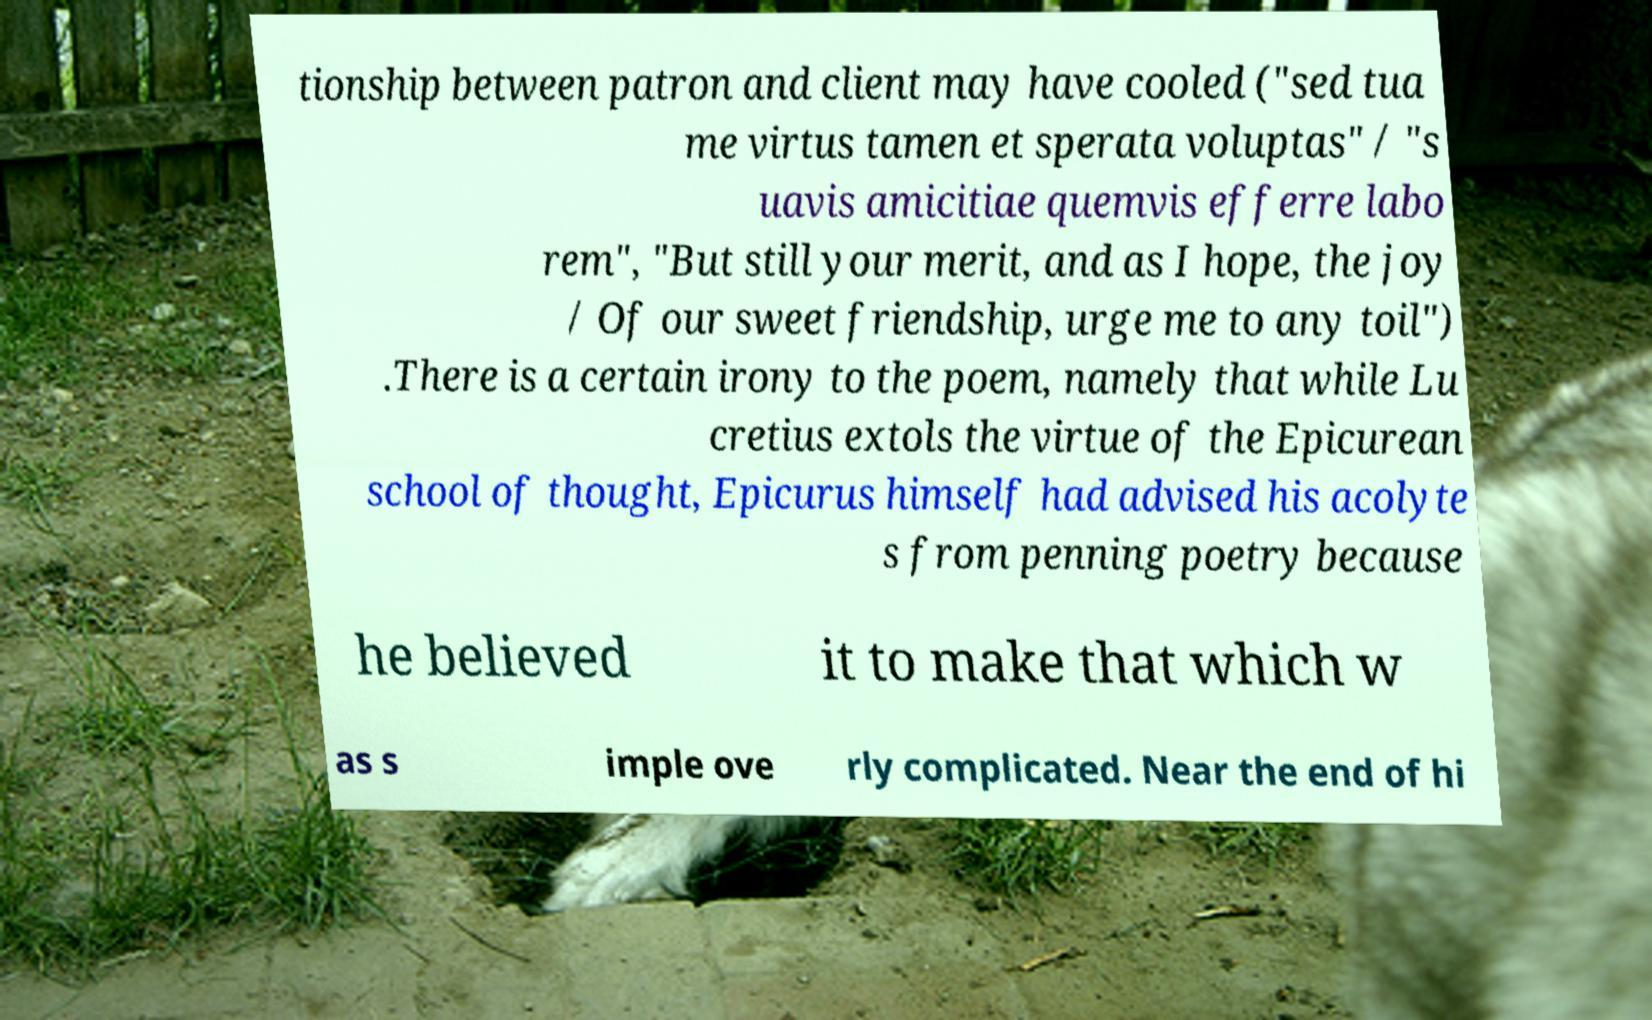I need the written content from this picture converted into text. Can you do that? tionship between patron and client may have cooled ("sed tua me virtus tamen et sperata voluptas" / "s uavis amicitiae quemvis efferre labo rem", "But still your merit, and as I hope, the joy / Of our sweet friendship, urge me to any toil") .There is a certain irony to the poem, namely that while Lu cretius extols the virtue of the Epicurean school of thought, Epicurus himself had advised his acolyte s from penning poetry because he believed it to make that which w as s imple ove rly complicated. Near the end of hi 